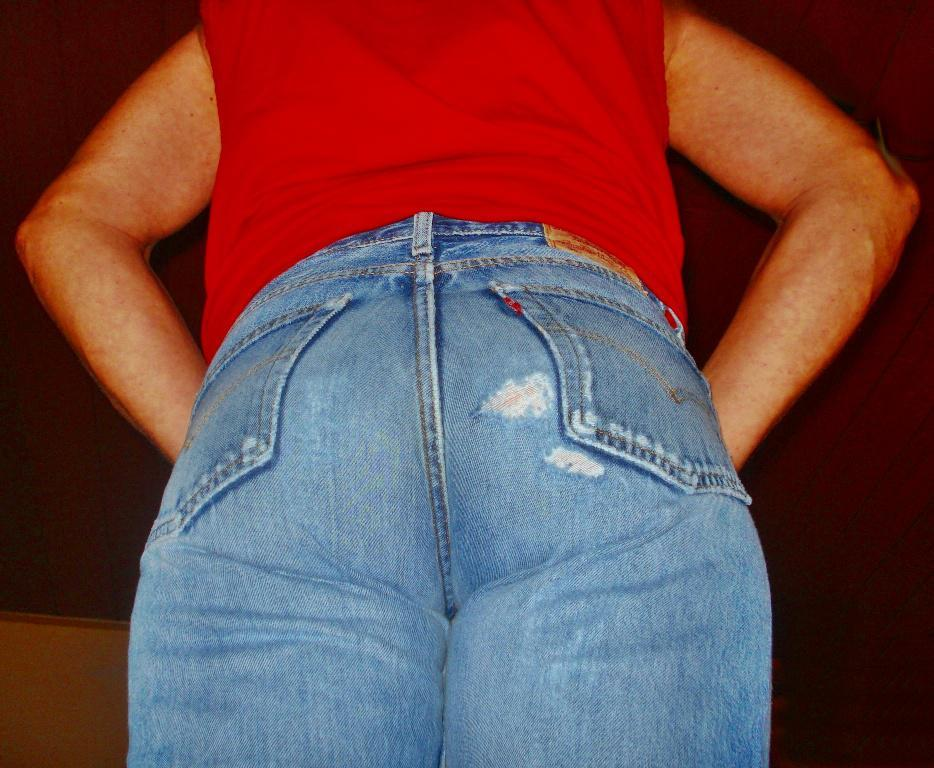What is the main subject of the image? The main subject of the image is a person. What type of clothing is the person wearing? The person is wearing jeans and a red t-shirt. What is the color of the background in the image? The background of the image is dark. What type of instrument is the person playing in the image? There is no instrument present in the image, and therefore no such activity can be observed. What is the condition of the bread in the image? There is no bread present in the image. 